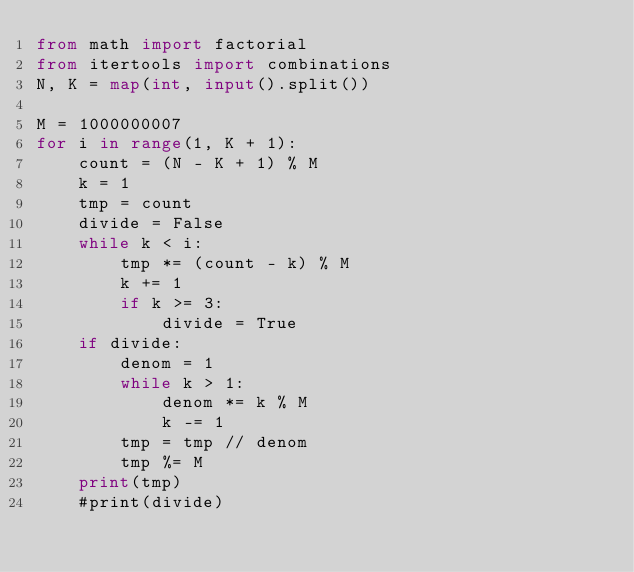<code> <loc_0><loc_0><loc_500><loc_500><_Python_>from math import factorial
from itertools import combinations
N, K = map(int, input().split())

M = 1000000007
for i in range(1, K + 1):
    count = (N - K + 1) % M
    k = 1
    tmp = count
    divide = False
    while k < i:
        tmp *= (count - k) % M
        k += 1
        if k >= 3:
            divide = True
    if divide:
        denom = 1
        while k > 1:
            denom *= k % M
            k -= 1
        tmp = tmp // denom
        tmp %= M
    print(tmp)
    #print(divide)</code> 